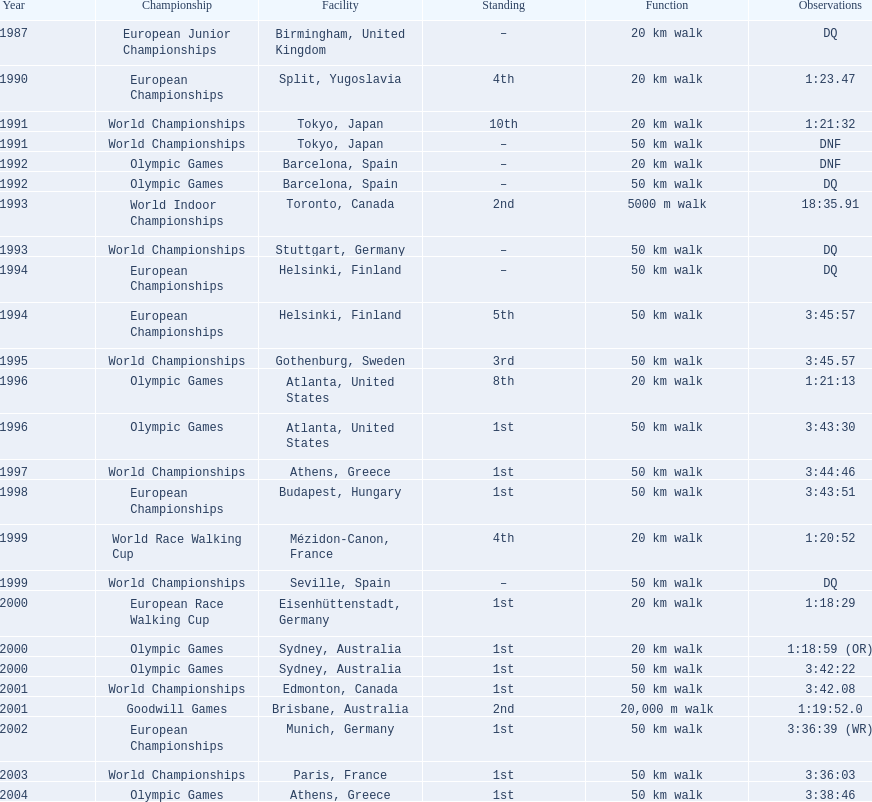What was the name of the competition that took place before the olympic games in 1996? World Championships. 